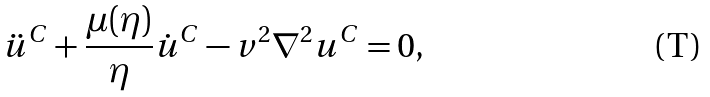Convert formula to latex. <formula><loc_0><loc_0><loc_500><loc_500>\ddot { u } ^ { C } + \frac { \mu ( \eta ) } { \eta } \dot { u } ^ { C } - v ^ { 2 } \nabla ^ { 2 } u ^ { C } = 0 ,</formula> 